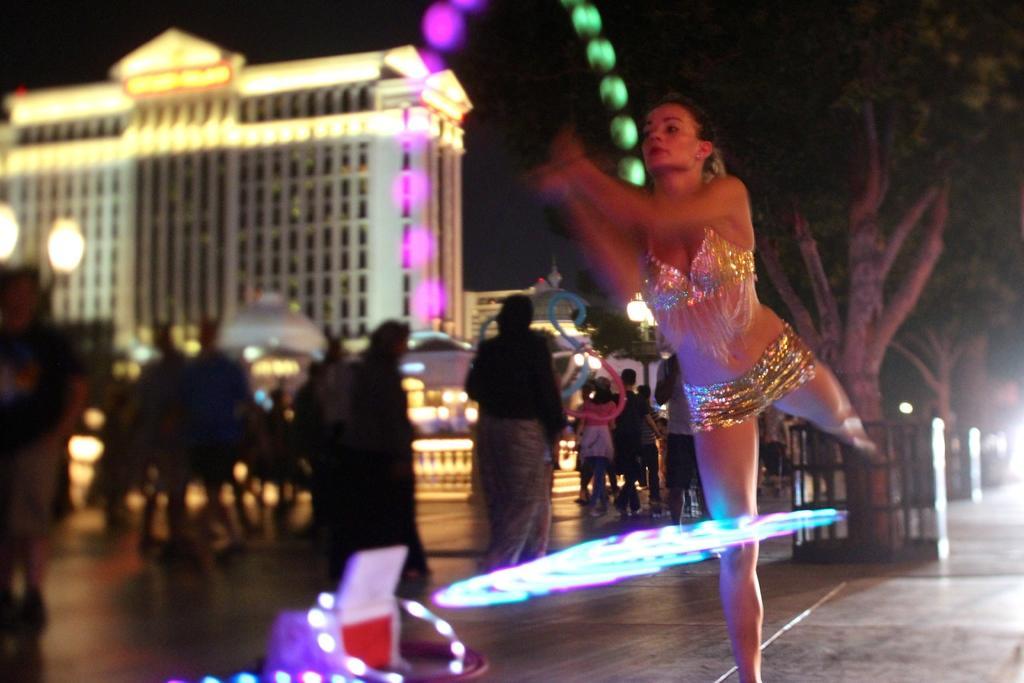Could you give a brief overview of what you see in this image? In this image we can see a woman is standing on the ground, here are the group of people standing on the floor, here is the tree, here is the building, here is the light. 